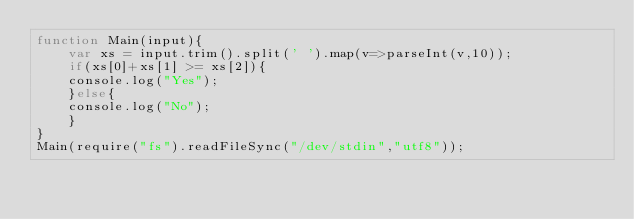Convert code to text. <code><loc_0><loc_0><loc_500><loc_500><_JavaScript_>function Main(input){
	var xs = input.trim().split(' ').map(v=>parseInt(v,10));
    if(xs[0]+xs[1] >= xs[2]){
    console.log("Yes");
    }else{
    console.log("No");
    }
}
Main(require("fs").readFileSync("/dev/stdin","utf8"));</code> 